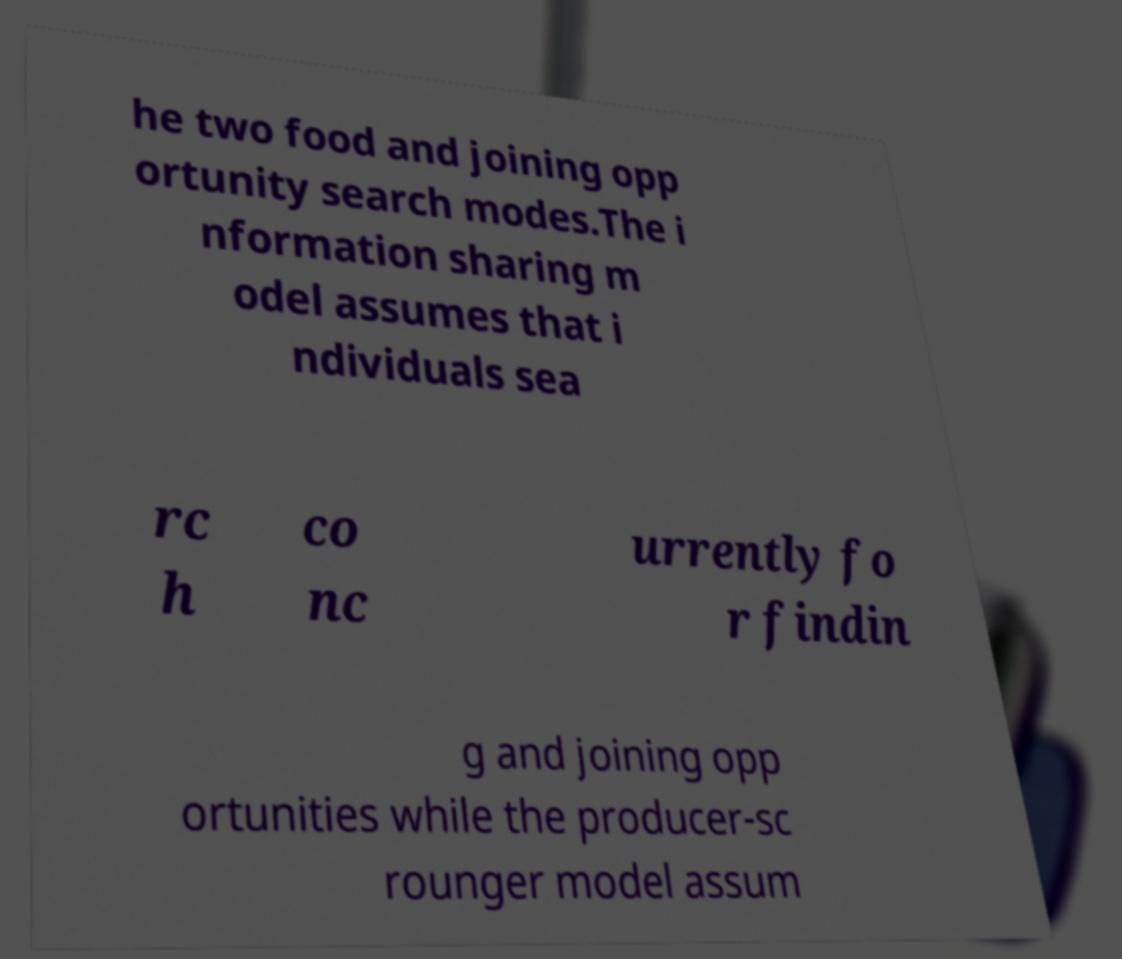For documentation purposes, I need the text within this image transcribed. Could you provide that? he two food and joining opp ortunity search modes.The i nformation sharing m odel assumes that i ndividuals sea rc h co nc urrently fo r findin g and joining opp ortunities while the producer-sc rounger model assum 